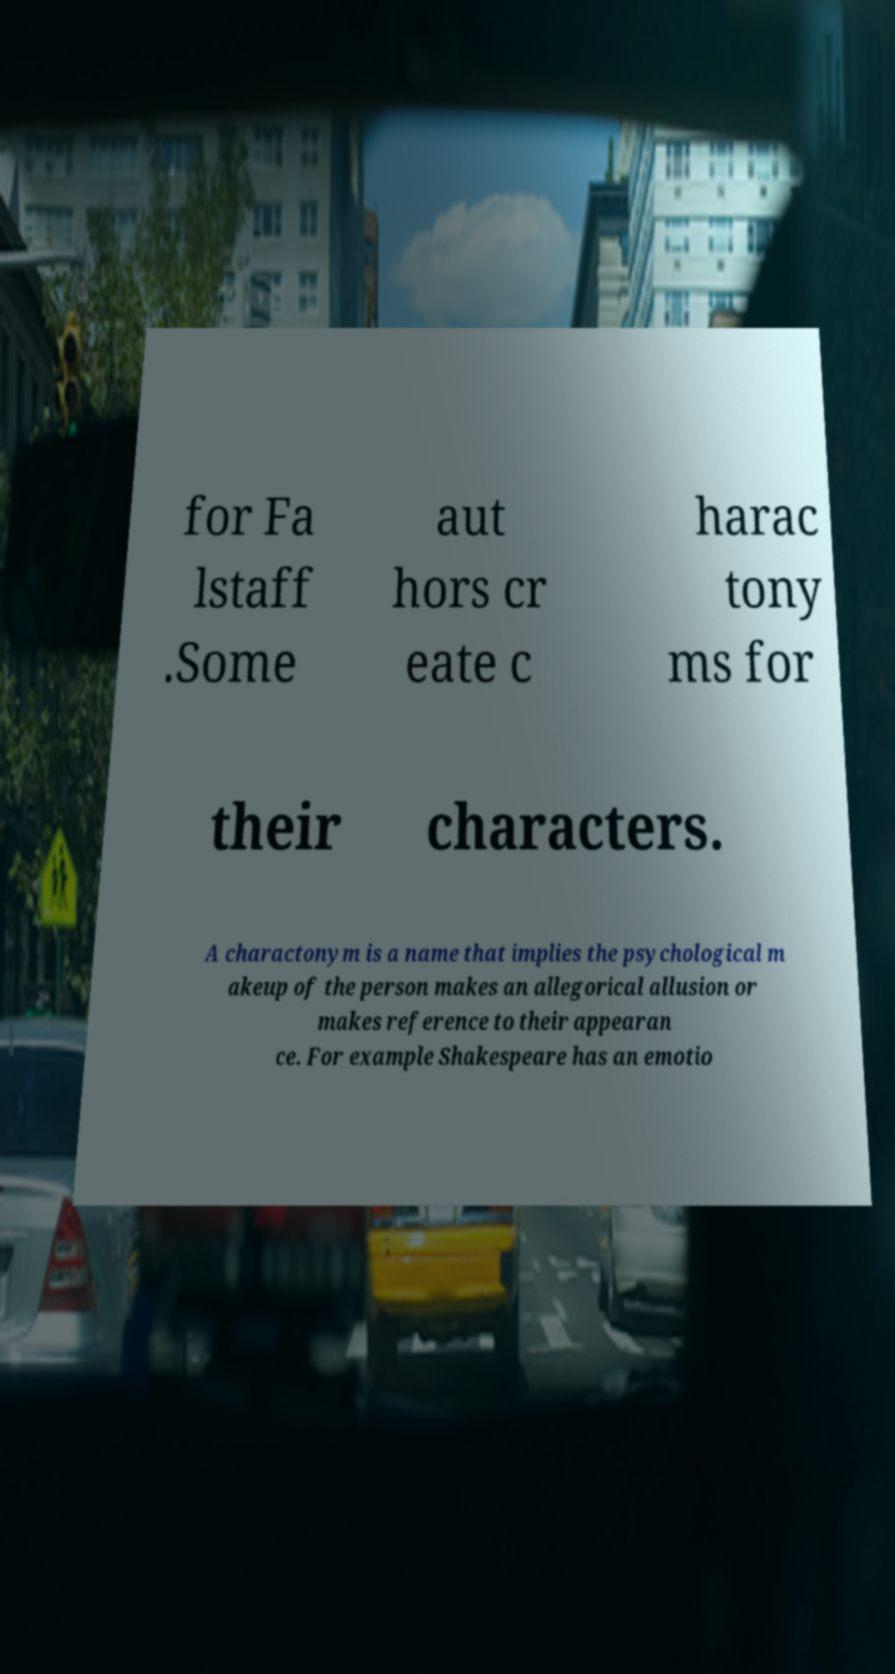I need the written content from this picture converted into text. Can you do that? for Fa lstaff .Some aut hors cr eate c harac tony ms for their characters. A charactonym is a name that implies the psychological m akeup of the person makes an allegorical allusion or makes reference to their appearan ce. For example Shakespeare has an emotio 